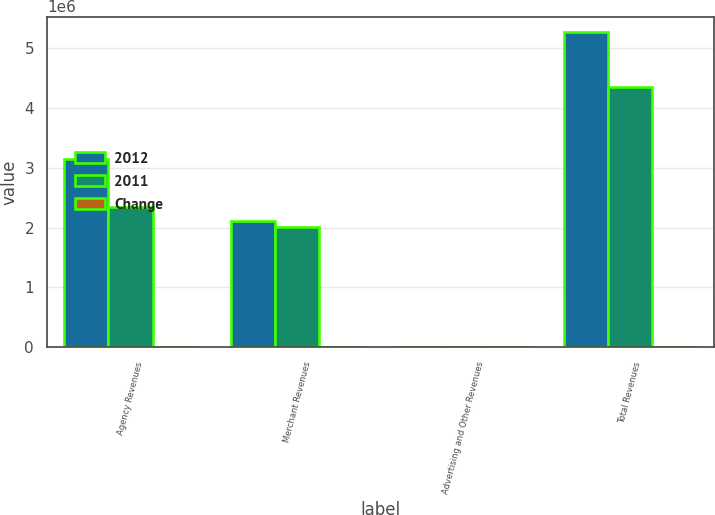Convert chart to OTSL. <chart><loc_0><loc_0><loc_500><loc_500><stacked_bar_chart><ecel><fcel>Agency Revenues<fcel>Merchant Revenues<fcel>Advertising and Other Revenues<fcel>Total Revenues<nl><fcel>2012<fcel>3.14282e+06<fcel>2.10475e+06<fcel>13389<fcel>5.26096e+06<nl><fcel>2011<fcel>2.33925e+06<fcel>2.00443e+06<fcel>11925<fcel>4.35561e+06<nl><fcel>Change<fcel>34.4<fcel>5<fcel>12.3<fcel>20.8<nl></chart> 